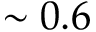<formula> <loc_0><loc_0><loc_500><loc_500>\sim 0 . 6</formula> 